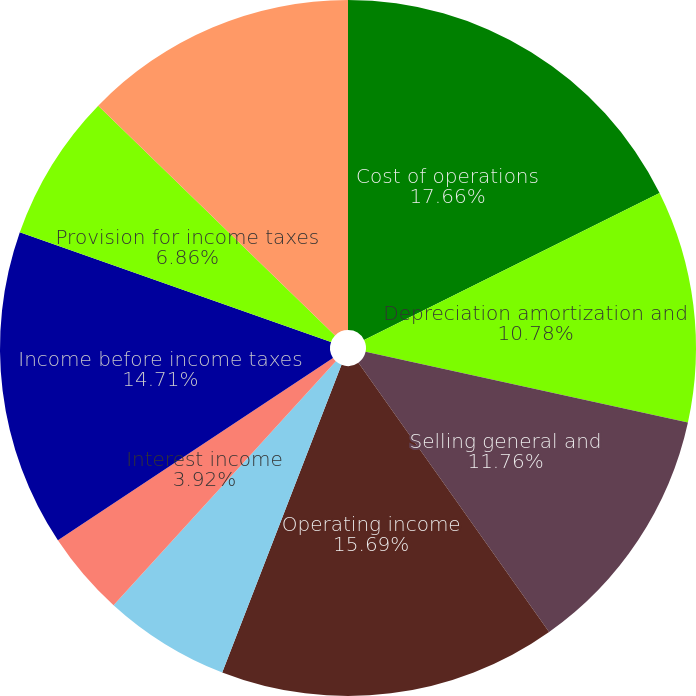Convert chart. <chart><loc_0><loc_0><loc_500><loc_500><pie_chart><fcel>Cost of operations<fcel>Depreciation amortization and<fcel>Selling general and<fcel>Operating income<fcel>Interest expense<fcel>Interest income<fcel>Other income (expense) net<fcel>Income before income taxes<fcel>Provision for income taxes<fcel>Income before cumulative<nl><fcel>17.65%<fcel>10.78%<fcel>11.76%<fcel>15.69%<fcel>5.88%<fcel>3.92%<fcel>0.0%<fcel>14.71%<fcel>6.86%<fcel>12.74%<nl></chart> 